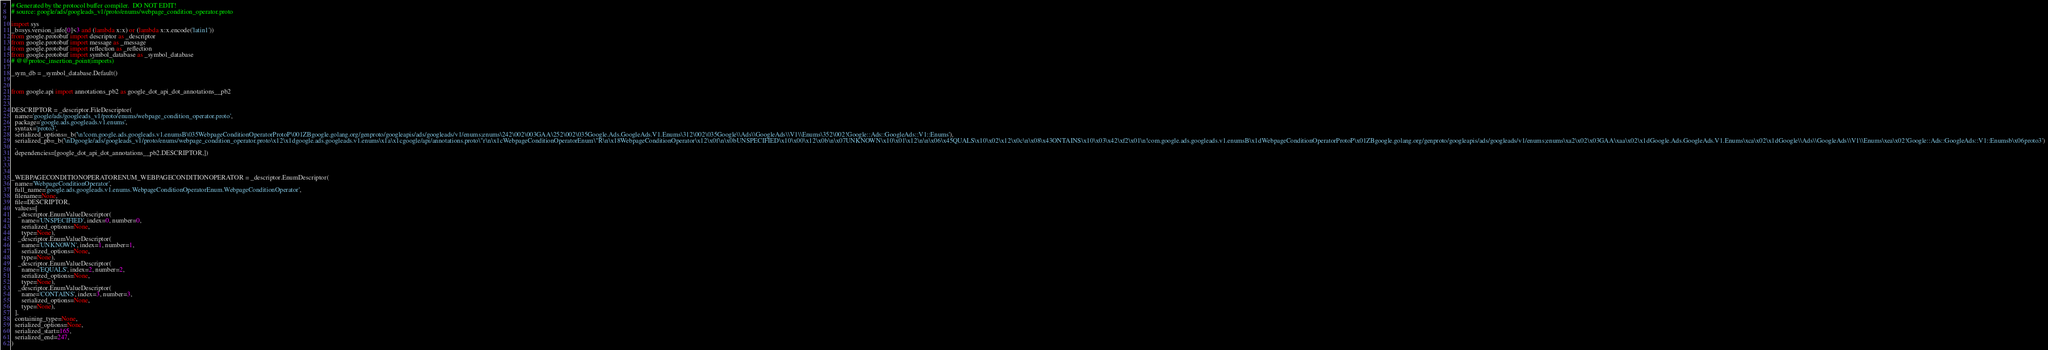Convert code to text. <code><loc_0><loc_0><loc_500><loc_500><_Python_># Generated by the protocol buffer compiler.  DO NOT EDIT!
# source: google/ads/googleads_v1/proto/enums/webpage_condition_operator.proto

import sys
_b=sys.version_info[0]<3 and (lambda x:x) or (lambda x:x.encode('latin1'))
from google.protobuf import descriptor as _descriptor
from google.protobuf import message as _message
from google.protobuf import reflection as _reflection
from google.protobuf import symbol_database as _symbol_database
# @@protoc_insertion_point(imports)

_sym_db = _symbol_database.Default()


from google.api import annotations_pb2 as google_dot_api_dot_annotations__pb2


DESCRIPTOR = _descriptor.FileDescriptor(
  name='google/ads/googleads_v1/proto/enums/webpage_condition_operator.proto',
  package='google.ads.googleads.v1.enums',
  syntax='proto3',
  serialized_options=_b('\n!com.google.ads.googleads.v1.enumsB\035WebpageConditionOperatorProtoP\001ZBgoogle.golang.org/genproto/googleapis/ads/googleads/v1/enums;enums\242\002\003GAA\252\002\035Google.Ads.GoogleAds.V1.Enums\312\002\035Google\\Ads\\GoogleAds\\V1\\Enums\352\002!Google::Ads::GoogleAds::V1::Enums'),
  serialized_pb=_b('\nDgoogle/ads/googleads_v1/proto/enums/webpage_condition_operator.proto\x12\x1dgoogle.ads.googleads.v1.enums\x1a\x1cgoogle/api/annotations.proto\"r\n\x1cWebpageConditionOperatorEnum\"R\n\x18WebpageConditionOperator\x12\x0f\n\x0bUNSPECIFIED\x10\x00\x12\x0b\n\x07UNKNOWN\x10\x01\x12\n\n\x06\x45QUALS\x10\x02\x12\x0c\n\x08\x43ONTAINS\x10\x03\x42\xf2\x01\n!com.google.ads.googleads.v1.enumsB\x1dWebpageConditionOperatorProtoP\x01ZBgoogle.golang.org/genproto/googleapis/ads/googleads/v1/enums;enums\xa2\x02\x03GAA\xaa\x02\x1dGoogle.Ads.GoogleAds.V1.Enums\xca\x02\x1dGoogle\\Ads\\GoogleAds\\V1\\Enums\xea\x02!Google::Ads::GoogleAds::V1::Enumsb\x06proto3')
  ,
  dependencies=[google_dot_api_dot_annotations__pb2.DESCRIPTOR,])



_WEBPAGECONDITIONOPERATORENUM_WEBPAGECONDITIONOPERATOR = _descriptor.EnumDescriptor(
  name='WebpageConditionOperator',
  full_name='google.ads.googleads.v1.enums.WebpageConditionOperatorEnum.WebpageConditionOperator',
  filename=None,
  file=DESCRIPTOR,
  values=[
    _descriptor.EnumValueDescriptor(
      name='UNSPECIFIED', index=0, number=0,
      serialized_options=None,
      type=None),
    _descriptor.EnumValueDescriptor(
      name='UNKNOWN', index=1, number=1,
      serialized_options=None,
      type=None),
    _descriptor.EnumValueDescriptor(
      name='EQUALS', index=2, number=2,
      serialized_options=None,
      type=None),
    _descriptor.EnumValueDescriptor(
      name='CONTAINS', index=3, number=3,
      serialized_options=None,
      type=None),
  ],
  containing_type=None,
  serialized_options=None,
  serialized_start=165,
  serialized_end=247,
)</code> 